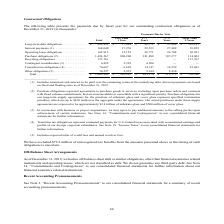According to First Solar's financial document, What are included in other obligations? Includes expected letter of credit fees and unused revolver fees.. The document states: "(5) Includes expected letter of credit fees and unused revolver fees...." Also, Why was $72.2 million of unrecognized tax benefits excluded? We have excluded $72.2 million of unrecognized tax benefits from the amounts presented above as the timing of such obligations is uncertain.. The document states: "We have excluded $72.2 million of unrecognized tax benefits from the amounts presented above as the timing of such obligations is uncertain...." Also, What do purchase obligations represent? Purchase obligations represent agreements to purchase goods or services, including open purchase orders and contracts with fixed volume commitments, that are noncancelable or cancelable with a significant penalty.. The document states: "(2) Purchase obligations represent agreements to purchase goods or services, including open purchase orders and contracts with fixed volume commitment..." Also, can you calculate: What percentage of the total contractual obligations is made up of total purchase obligations? Based on the calculation: 1,424,267/2,469,962 , the result is 57.66 (percentage). This is based on the information: "ations (5) . 10,527 2,933 5,164 2,430 — Total . $ 2,469,962 $ 962,261 $ 403,174 $ 313,579 $ 790,948 28,771 26,708 92,281 Purchase obligations (2). . 1,424,267 900,200 221,888 187,277 114,902 Recycling..." The key data points involved are: 1,424,267, 2,469,962. Also, can you calculate: What percentage of the total contractual obligations is made up of total long-term debt obligations? Based on the calculation: 482,892/2,469,962 , the result is 19.55 (percentage). This is based on the information: "More Than 5 Years Long-term debt obligations . $ 482,892 $ 17,684 $ 98,571 $ 37,496 $ 329,141 Interest payments (1) . 168,040 17,276 29,533 27,409 93,822 Op ations (5) . 10,527 2,933 5,164 2,430 — Tot..." The key data points involved are: 2,469,962, 482,892. Also, can you calculate: What difference between total interest payments and total operating lease obligations? Based on the calculation: 168,040 - 162,913 , the result is 5127 (in thousands). This is based on the information: "9,533 27,409 93,822 Operating lease obligations . 162,913 15,153 28,771 26,708 92,281 Purchase obligations (2). . 1,424,267 900,200 221,888 187,277 114,902 R 98,571 $ 37,496 $ 329,141 Interest payment..." The key data points involved are: 162,913, 168,040. 